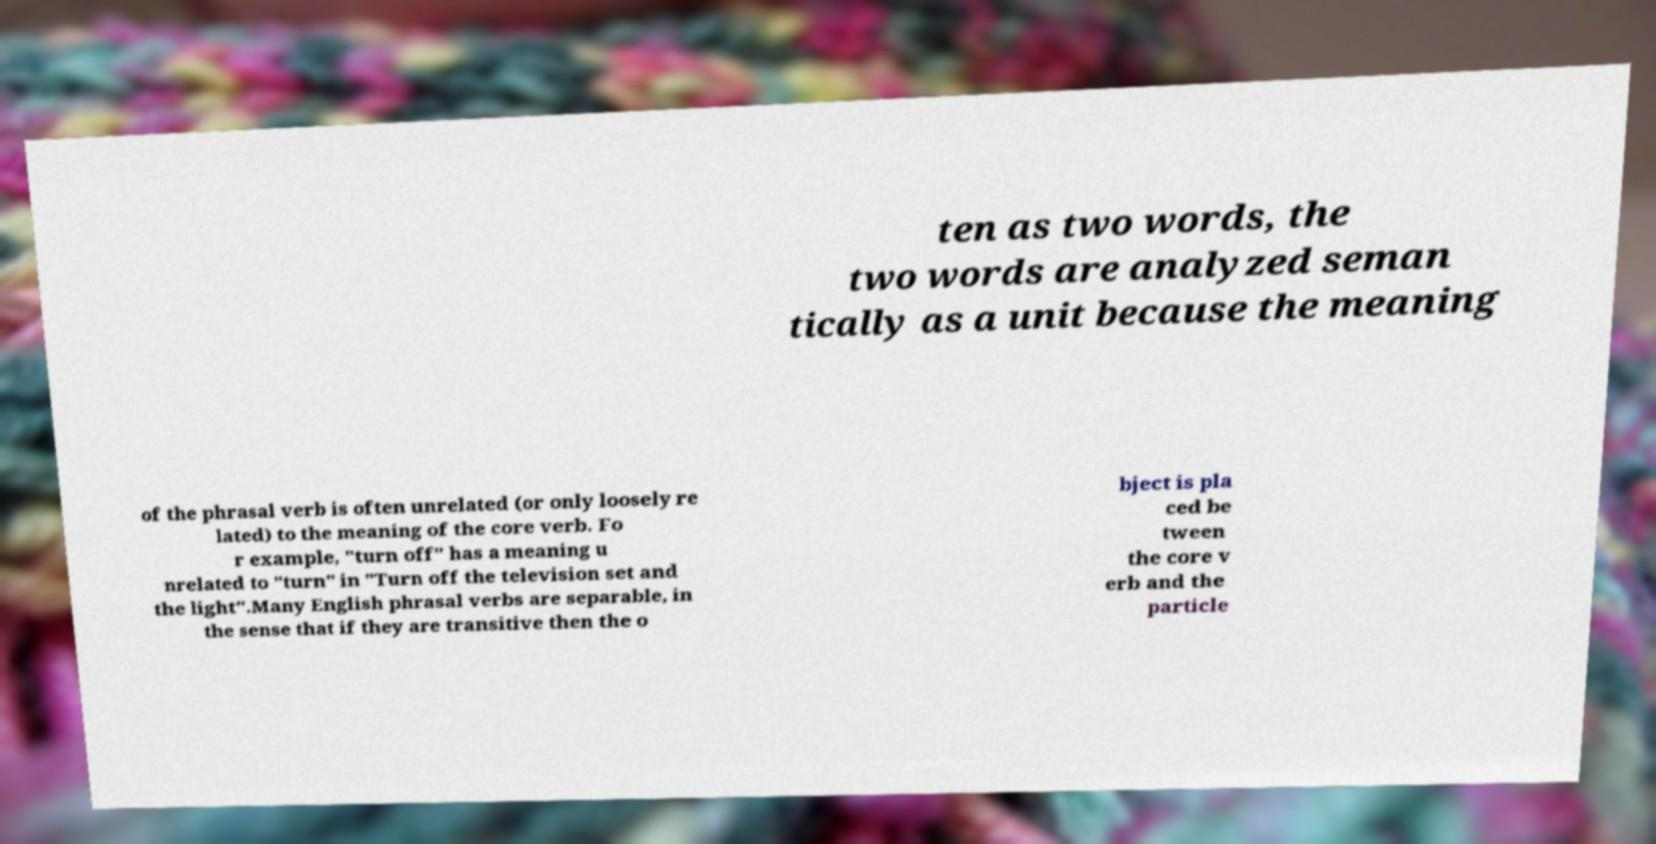I need the written content from this picture converted into text. Can you do that? ten as two words, the two words are analyzed seman tically as a unit because the meaning of the phrasal verb is often unrelated (or only loosely re lated) to the meaning of the core verb. Fo r example, "turn off" has a meaning u nrelated to "turn" in "Turn off the television set and the light".Many English phrasal verbs are separable, in the sense that if they are transitive then the o bject is pla ced be tween the core v erb and the particle 